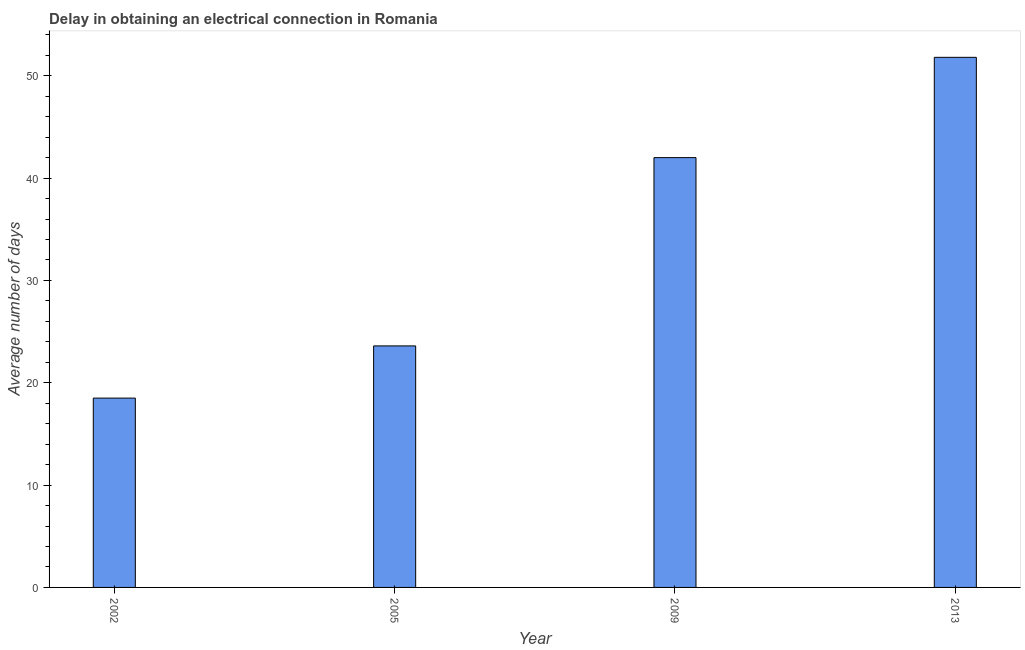What is the title of the graph?
Give a very brief answer. Delay in obtaining an electrical connection in Romania. What is the label or title of the Y-axis?
Provide a succinct answer. Average number of days. Across all years, what is the maximum dalay in electrical connection?
Offer a very short reply. 51.8. What is the sum of the dalay in electrical connection?
Your response must be concise. 135.9. What is the difference between the dalay in electrical connection in 2005 and 2013?
Provide a short and direct response. -28.2. What is the average dalay in electrical connection per year?
Your response must be concise. 33.98. What is the median dalay in electrical connection?
Make the answer very short. 32.8. In how many years, is the dalay in electrical connection greater than 10 days?
Ensure brevity in your answer.  4. What is the ratio of the dalay in electrical connection in 2005 to that in 2009?
Keep it short and to the point. 0.56. What is the difference between the highest and the second highest dalay in electrical connection?
Ensure brevity in your answer.  9.8. What is the difference between the highest and the lowest dalay in electrical connection?
Your response must be concise. 33.3. In how many years, is the dalay in electrical connection greater than the average dalay in electrical connection taken over all years?
Your answer should be compact. 2. How many bars are there?
Make the answer very short. 4. How many years are there in the graph?
Your answer should be very brief. 4. Are the values on the major ticks of Y-axis written in scientific E-notation?
Your answer should be compact. No. What is the Average number of days in 2005?
Provide a short and direct response. 23.6. What is the Average number of days of 2013?
Your answer should be very brief. 51.8. What is the difference between the Average number of days in 2002 and 2009?
Provide a succinct answer. -23.5. What is the difference between the Average number of days in 2002 and 2013?
Keep it short and to the point. -33.3. What is the difference between the Average number of days in 2005 and 2009?
Keep it short and to the point. -18.4. What is the difference between the Average number of days in 2005 and 2013?
Provide a short and direct response. -28.2. What is the ratio of the Average number of days in 2002 to that in 2005?
Make the answer very short. 0.78. What is the ratio of the Average number of days in 2002 to that in 2009?
Your answer should be very brief. 0.44. What is the ratio of the Average number of days in 2002 to that in 2013?
Give a very brief answer. 0.36. What is the ratio of the Average number of days in 2005 to that in 2009?
Provide a succinct answer. 0.56. What is the ratio of the Average number of days in 2005 to that in 2013?
Provide a short and direct response. 0.46. What is the ratio of the Average number of days in 2009 to that in 2013?
Ensure brevity in your answer.  0.81. 